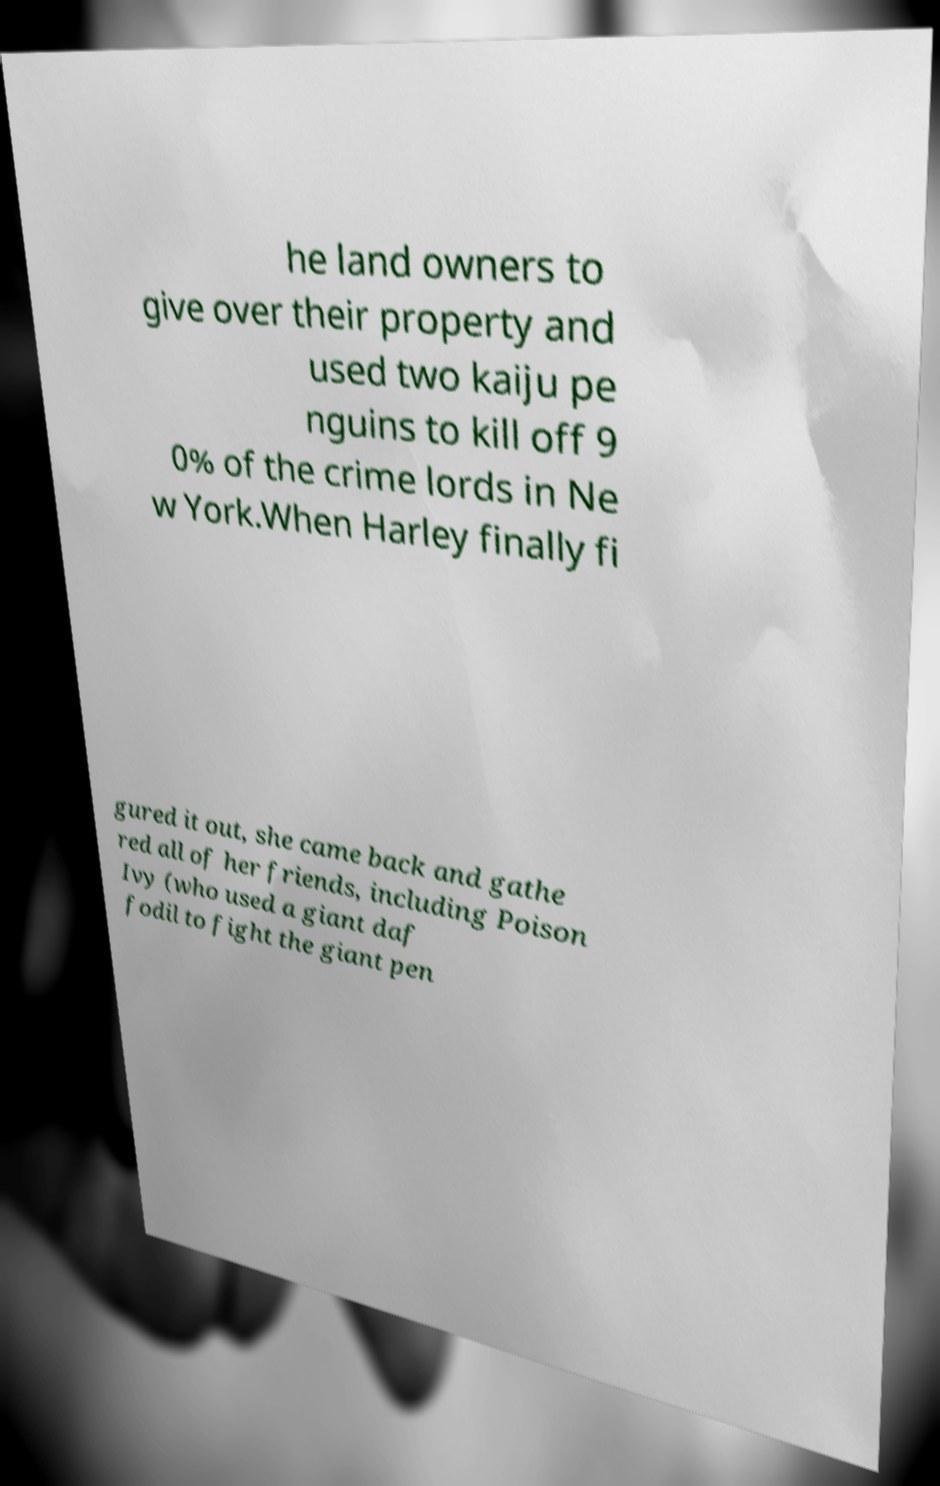Can you read and provide the text displayed in the image?This photo seems to have some interesting text. Can you extract and type it out for me? he land owners to give over their property and used two kaiju pe nguins to kill off 9 0% of the crime lords in Ne w York.When Harley finally fi gured it out, she came back and gathe red all of her friends, including Poison Ivy (who used a giant daf fodil to fight the giant pen 